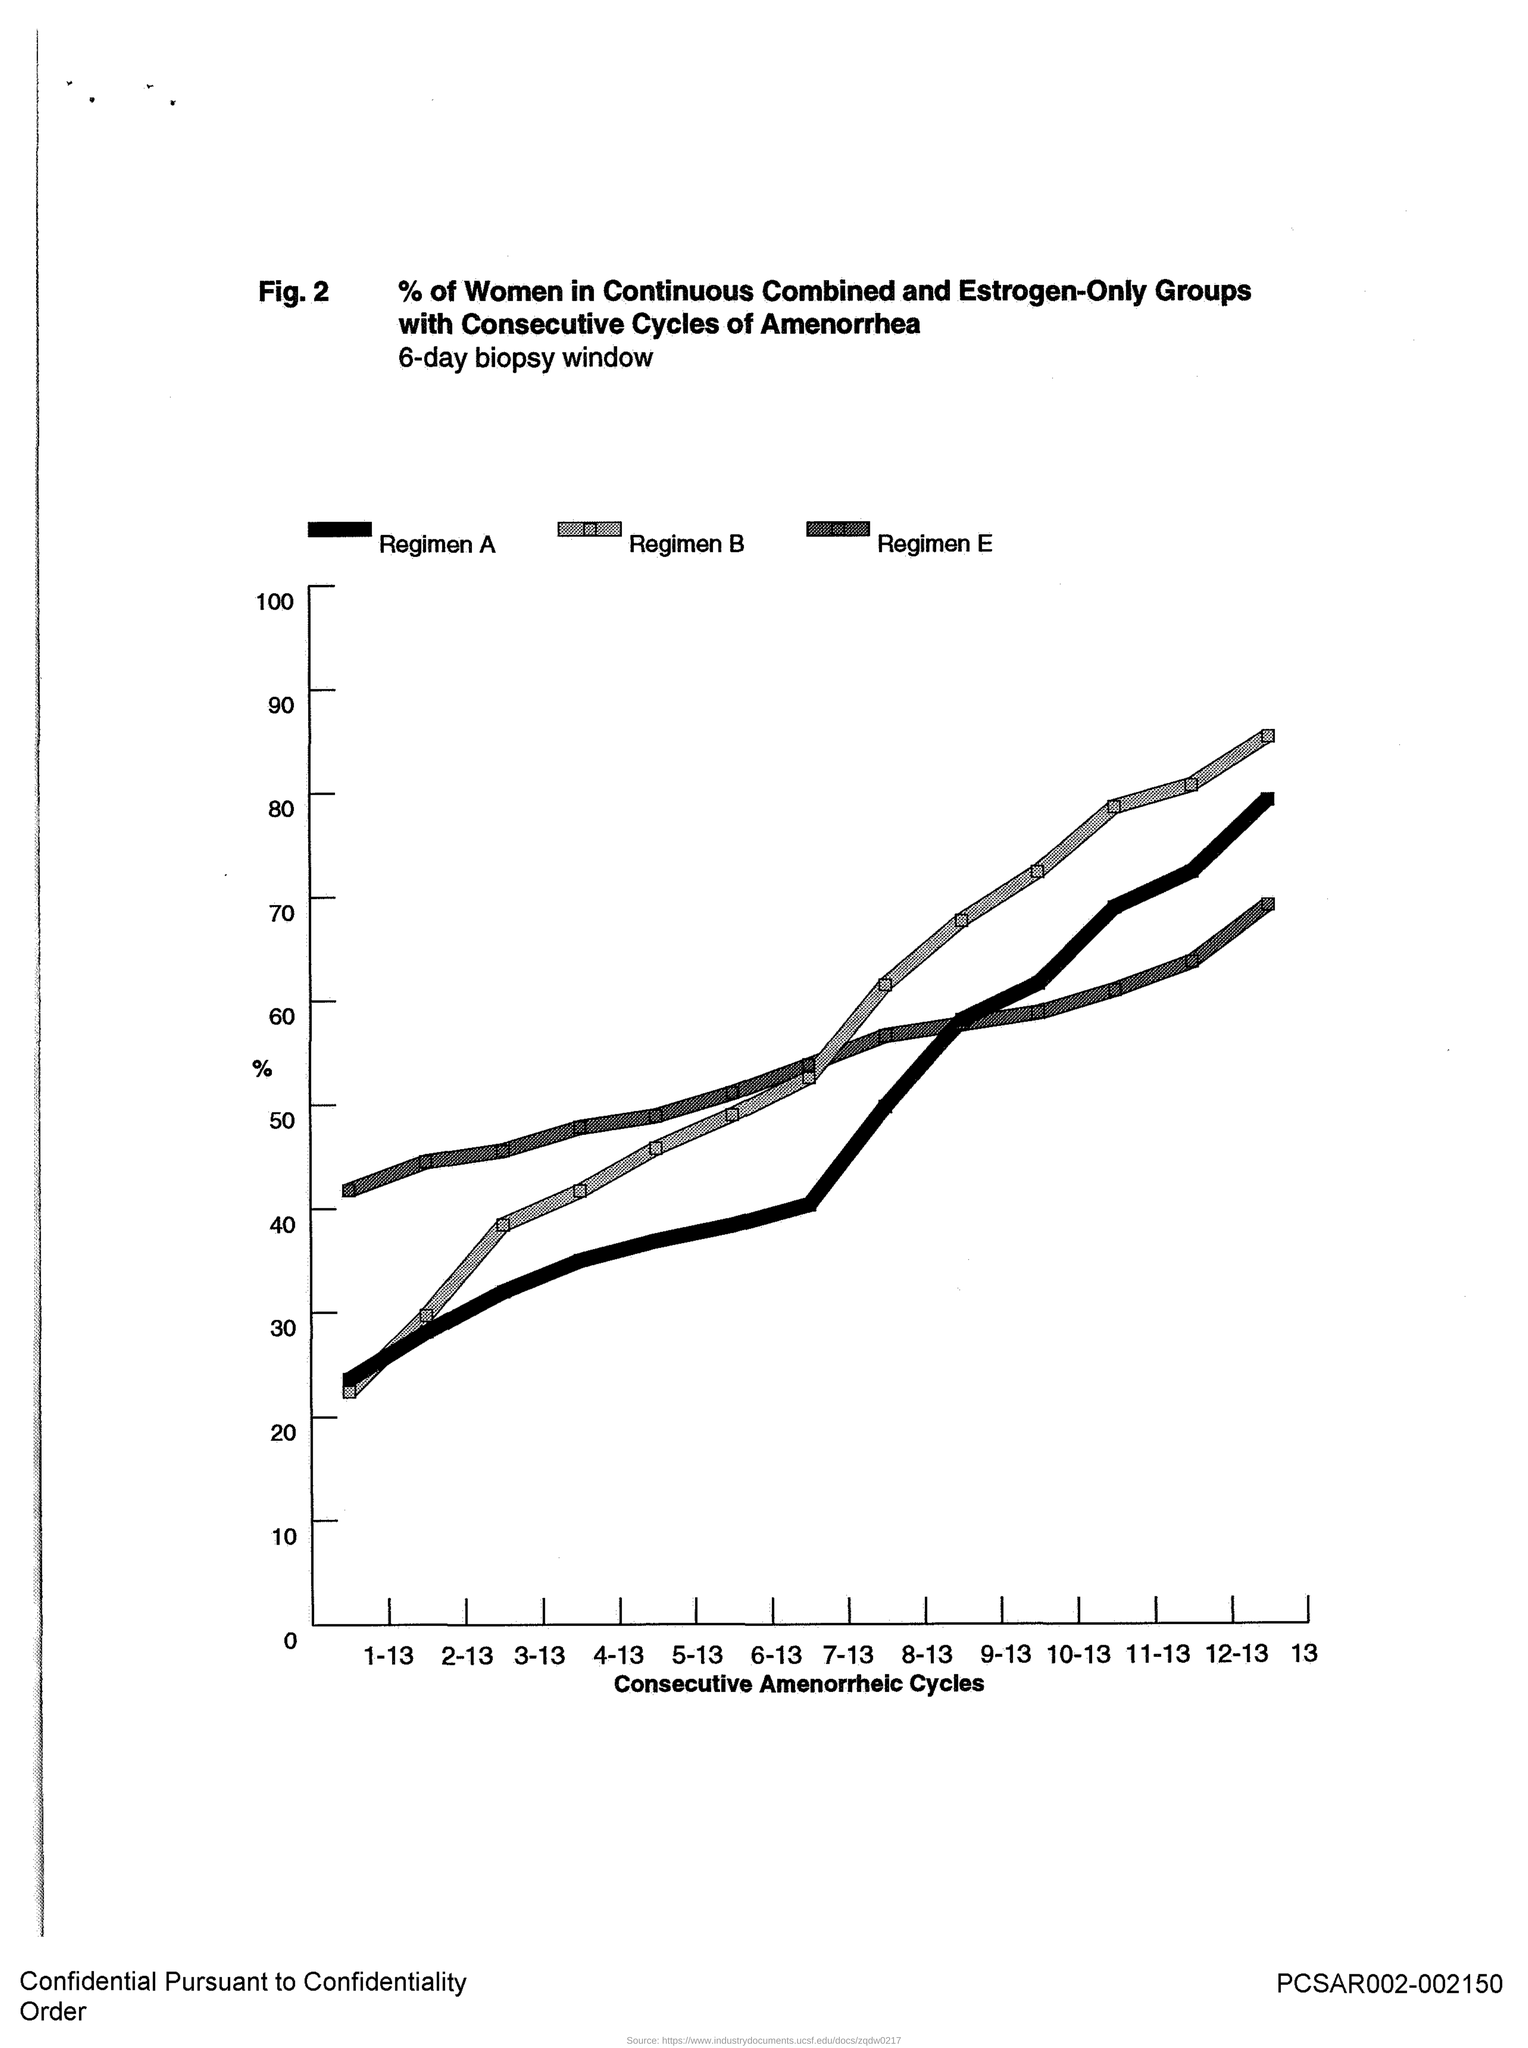Give some essential details in this illustration. This study focuses on analyzing the trends in consecutive amenorrheic cycles in patients with primary ovarian insufficiency, with the aim of identifying potential triggers for amenorrhea and determining the optimal management strategies for these patients. 